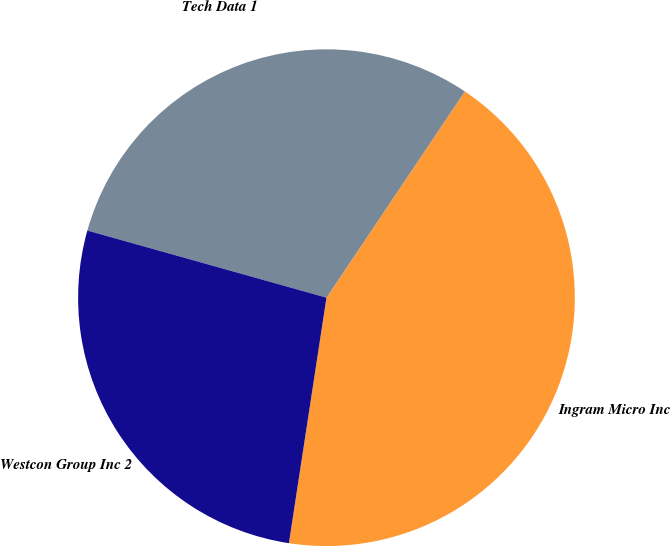Convert chart. <chart><loc_0><loc_0><loc_500><loc_500><pie_chart><fcel>Ingram Micro Inc<fcel>Tech Data 1<fcel>Westcon Group Inc 2<nl><fcel>43.01%<fcel>30.05%<fcel>26.94%<nl></chart> 